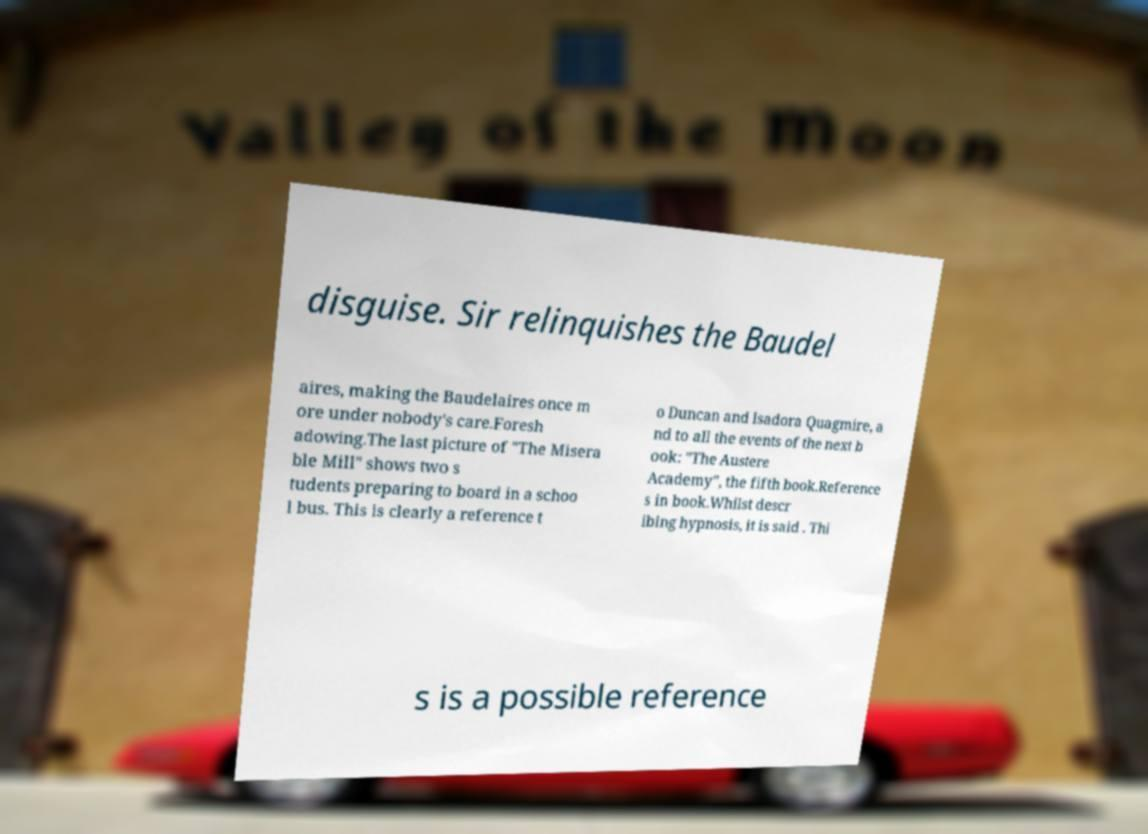Can you accurately transcribe the text from the provided image for me? disguise. Sir relinquishes the Baudel aires, making the Baudelaires once m ore under nobody's care.Foresh adowing.The last picture of "The Misera ble Mill" shows two s tudents preparing to board in a schoo l bus. This is clearly a reference t o Duncan and Isadora Quagmire, a nd to all the events of the next b ook: "The Austere Academy", the fifth book.Reference s in book.Whilst descr ibing hypnosis, it is said . Thi s is a possible reference 